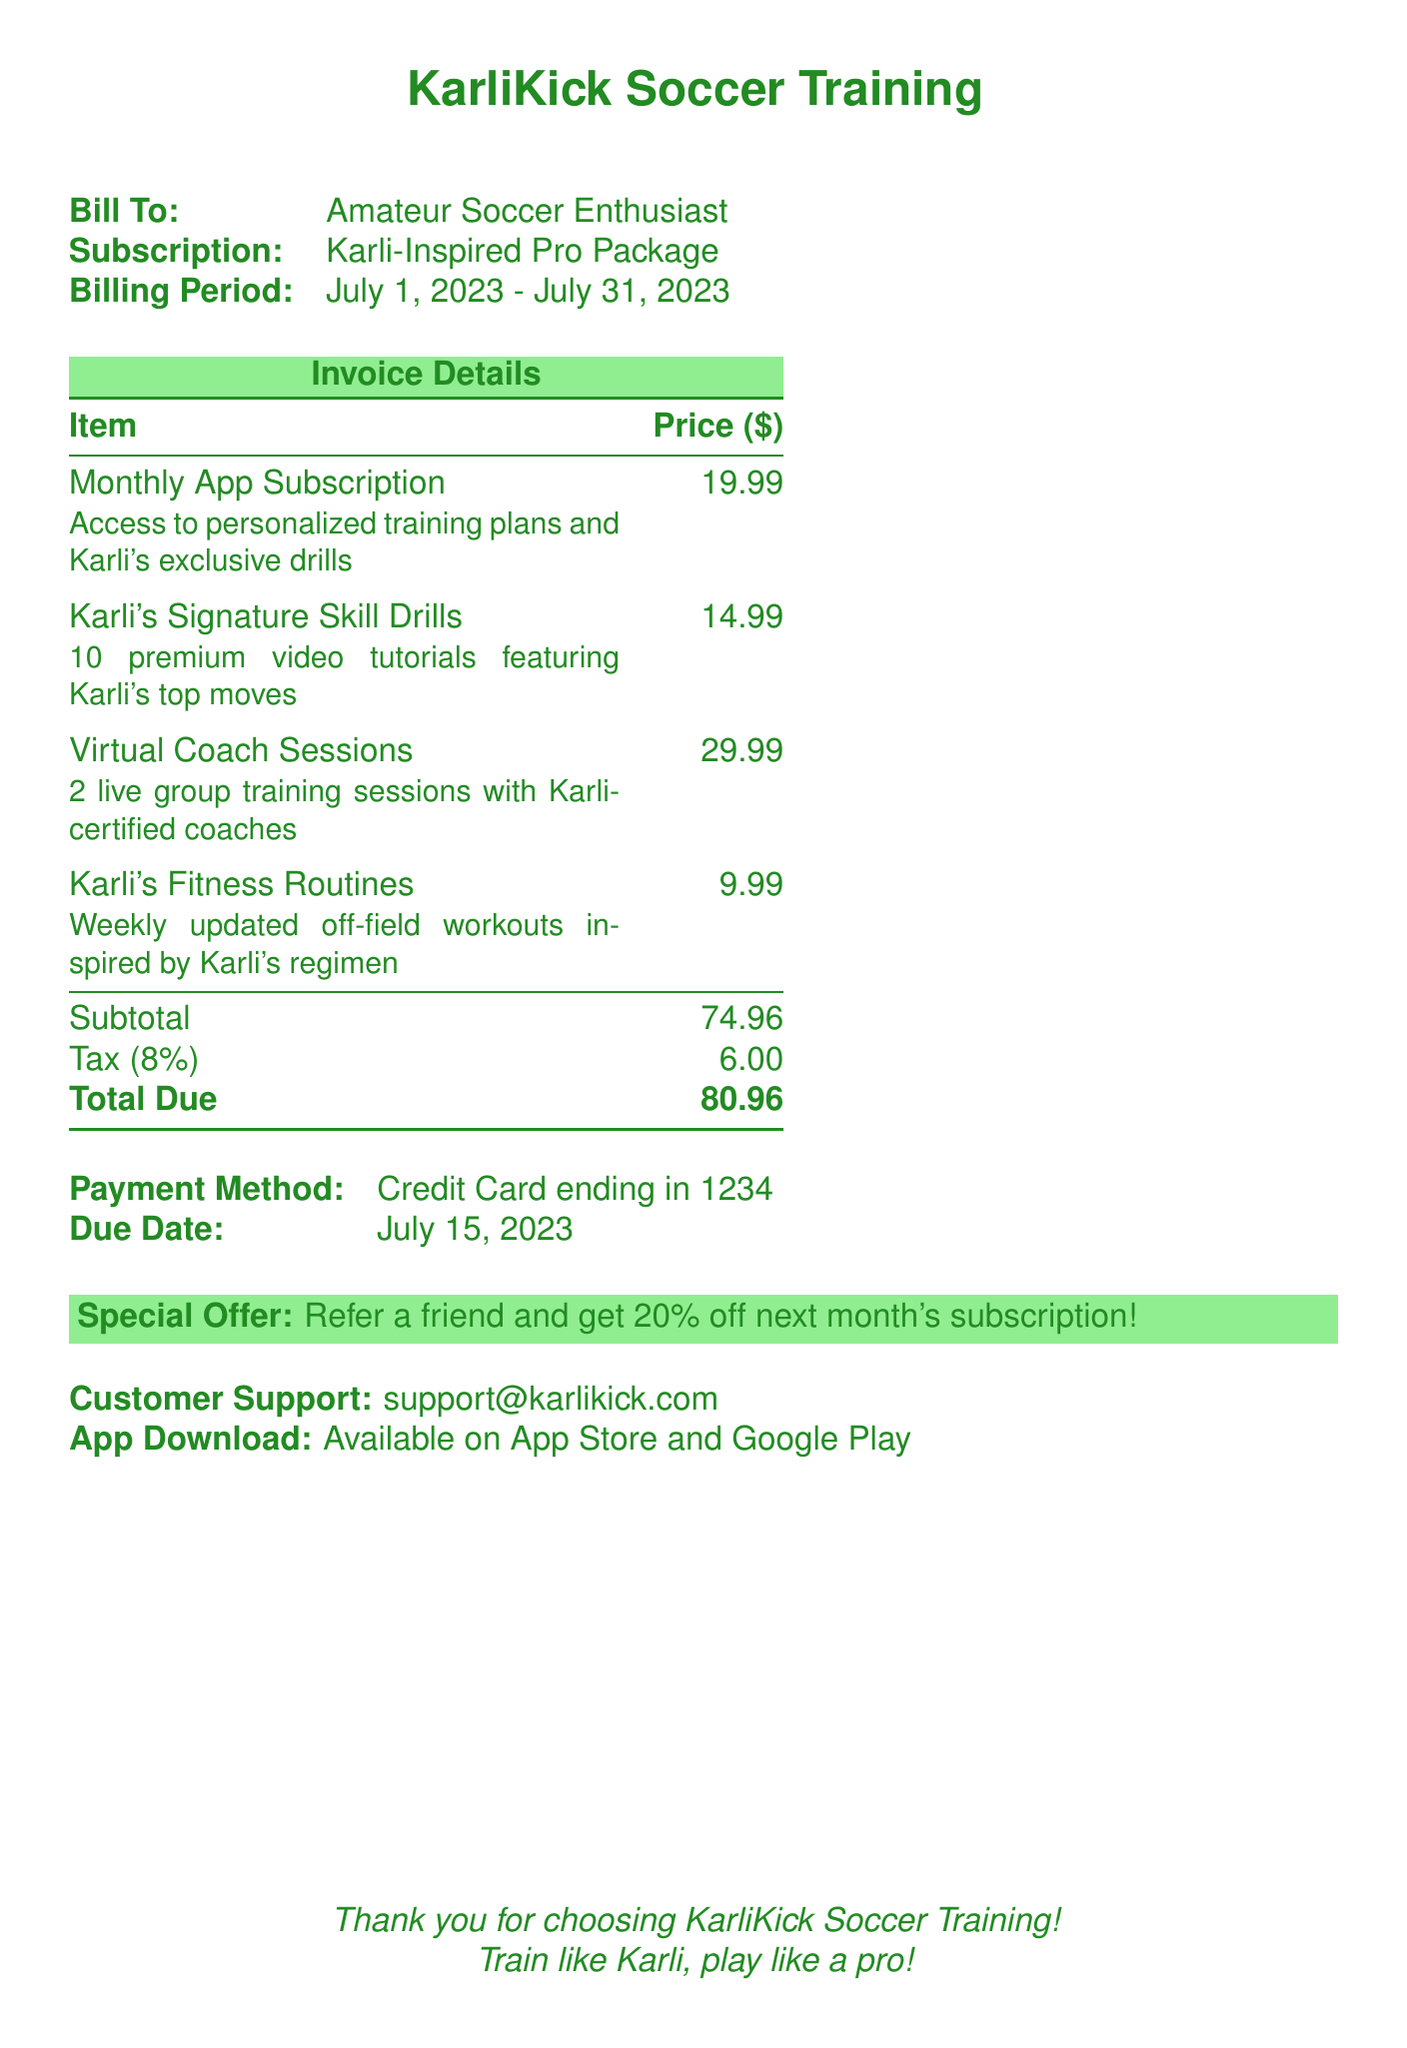What is the billing period? The billing period indicates the time frame for which the subscription is active, which is detailed in the document.
Answer: July 1, 2023 - July 31, 2023 What is the total due amount? The total due is the final amount to be paid after taxes are included, as stated in the invoice.
Answer: 80.96 What is the price of Karli's Fitness Routines? The document lists the cost for each item, including Karli's Fitness Routines, which is mentioned explicitly.
Answer: 9.99 How much is the tax applied? The tax amount is specified separately in the invoice, showing what percentage is added to the subtotal.
Answer: 6.00 What is the special offer mentioned? The document provides an incentive for referring friends, highlighting a specific discount offer clearly.
Answer: Refer a friend and get 20% off next month's subscription! How many live group training sessions are included? The number of training sessions included in the Virtual Coach Sessions is clearly stated in the invoice details.
Answer: 2 What is the name of the app? The invoice title indicates the name of the service that the subscription applies to.
Answer: KarliKick Soccer Training What payment method is used? The document specifies the type of payment method used for the subscription, indicating with partial information.
Answer: Credit Card ending in 1234 